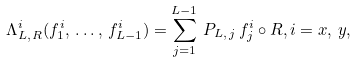Convert formula to latex. <formula><loc_0><loc_0><loc_500><loc_500>\Lambda ^ { i } _ { L , \, R } ( f _ { 1 } ^ { i } , \, \dots , \, f _ { L - 1 } ^ { i } ) = \sum _ { j = 1 } ^ { L - 1 } \, P _ { L , \, j } \, f _ { j } ^ { i } \circ R , i = x , \, y ,</formula> 